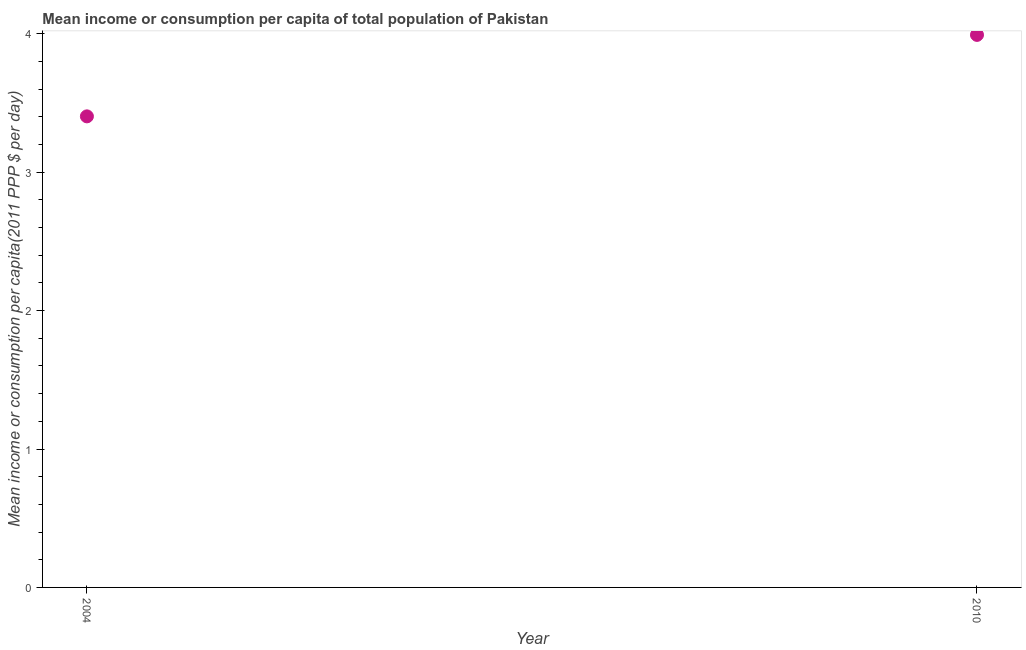What is the mean income or consumption in 2010?
Offer a very short reply. 3.99. Across all years, what is the maximum mean income or consumption?
Make the answer very short. 3.99. Across all years, what is the minimum mean income or consumption?
Keep it short and to the point. 3.4. In which year was the mean income or consumption minimum?
Give a very brief answer. 2004. What is the sum of the mean income or consumption?
Give a very brief answer. 7.4. What is the difference between the mean income or consumption in 2004 and 2010?
Make the answer very short. -0.59. What is the average mean income or consumption per year?
Provide a short and direct response. 3.7. What is the median mean income or consumption?
Your response must be concise. 3.7. Do a majority of the years between 2004 and 2010 (inclusive) have mean income or consumption greater than 2 $?
Provide a succinct answer. Yes. What is the ratio of the mean income or consumption in 2004 to that in 2010?
Provide a succinct answer. 0.85. Does the graph contain any zero values?
Give a very brief answer. No. What is the title of the graph?
Provide a succinct answer. Mean income or consumption per capita of total population of Pakistan. What is the label or title of the Y-axis?
Your response must be concise. Mean income or consumption per capita(2011 PPP $ per day). What is the Mean income or consumption per capita(2011 PPP $ per day) in 2004?
Provide a succinct answer. 3.4. What is the Mean income or consumption per capita(2011 PPP $ per day) in 2010?
Provide a succinct answer. 3.99. What is the difference between the Mean income or consumption per capita(2011 PPP $ per day) in 2004 and 2010?
Offer a very short reply. -0.59. What is the ratio of the Mean income or consumption per capita(2011 PPP $ per day) in 2004 to that in 2010?
Ensure brevity in your answer.  0.85. 